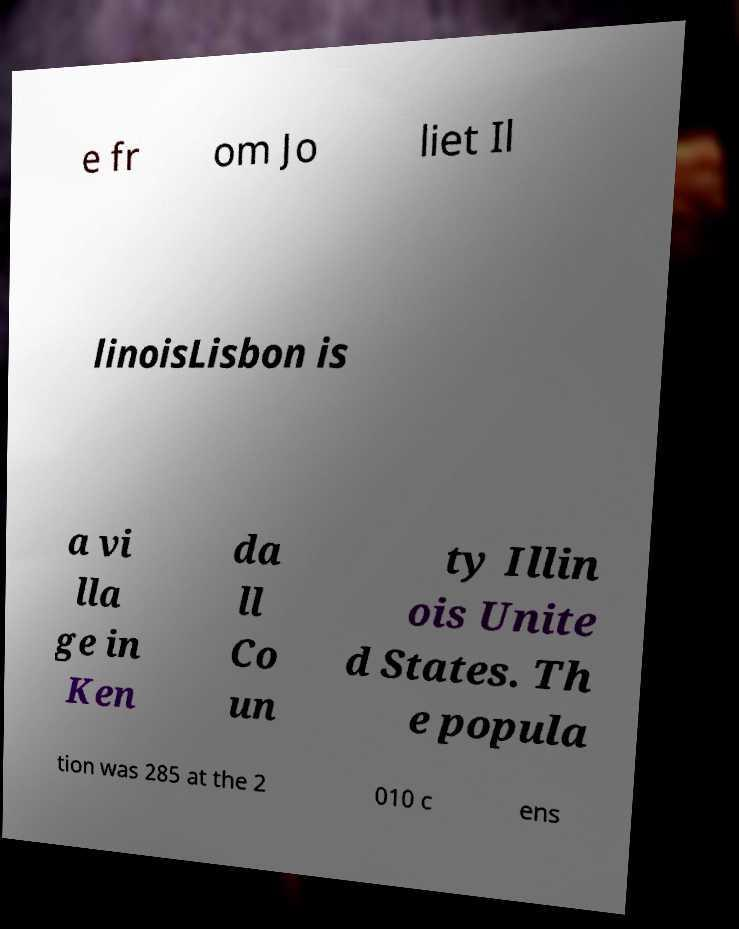Please identify and transcribe the text found in this image. e fr om Jo liet Il linoisLisbon is a vi lla ge in Ken da ll Co un ty Illin ois Unite d States. Th e popula tion was 285 at the 2 010 c ens 